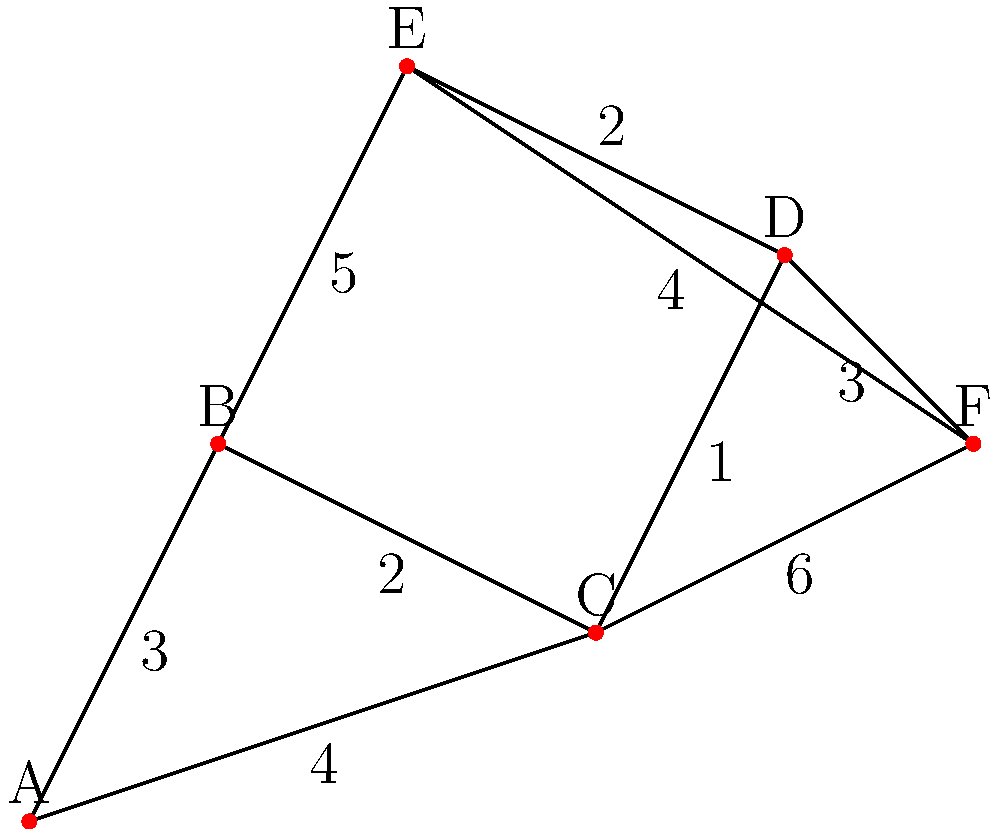As a sales agent and tennis enthusiast, you're planning to visit multiple tennis courts in your area. The map above shows the network of tennis courts (A to F) and the distances between them. What is the shortest path from court A to court F, and what is its total distance? To find the shortest path from court A to court F, we'll use Dijkstra's algorithm:

1. Initialize:
   - Distance to A: 0
   - Distance to all other vertices: infinity
   - Previous vertex for all: undefined
   - Unvisited set: {A, B, C, D, E, F}

2. Start from A:
   - Update distances: B(3), C(4)
   - Mark A as visited

3. Visit B (closest unvisited vertex):
   - Update distances: C(min(4, 3+2)=3), E(3+5=8)
   - Mark B as visited

4. Visit C (closest unvisited vertex):
   - Update distances: D(3+1=4), F(3+6=9)
   - Mark C as visited

5. Visit D (closest unvisited vertex):
   - Update distances: E(min(8, 4+2)=6), F(min(9, 4+3)=7)
   - Mark D as visited

6. Visit F (closest unvisited vertex):
   - No updates needed
   - Mark F as visited

The shortest path is found: A → B → C → D → F
Total distance: 3 + 2 + 1 + 3 = 9
Answer: A → B → C → D → F, 9 units 